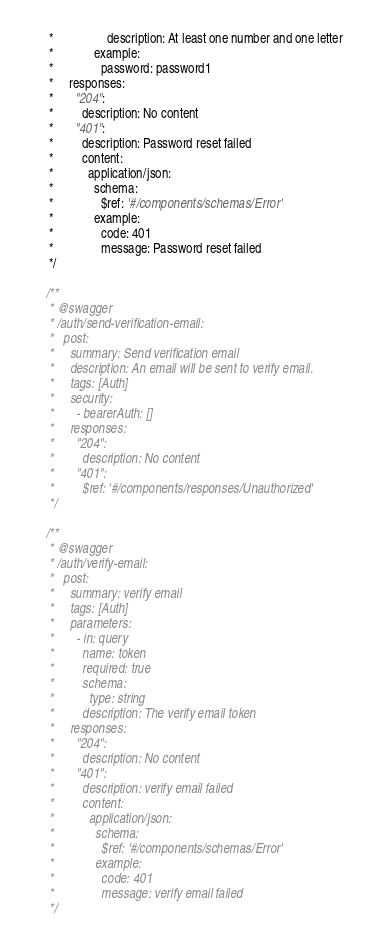Convert code to text. <code><loc_0><loc_0><loc_500><loc_500><_JavaScript_> *                 description: At least one number and one letter
 *             example:
 *               password: password1
 *     responses:
 *       "204":
 *         description: No content
 *       "401":
 *         description: Password reset failed
 *         content:
 *           application/json:
 *             schema:
 *               $ref: '#/components/schemas/Error'
 *             example:
 *               code: 401
 *               message: Password reset failed
 */

/**
 * @swagger
 * /auth/send-verification-email:
 *   post:
 *     summary: Send verification email
 *     description: An email will be sent to verify email.
 *     tags: [Auth]
 *     security:
 *       - bearerAuth: []
 *     responses:
 *       "204":
 *         description: No content
 *       "401":
 *         $ref: '#/components/responses/Unauthorized'
 */

/**
 * @swagger
 * /auth/verify-email:
 *   post:
 *     summary: verify email
 *     tags: [Auth]
 *     parameters:
 *       - in: query
 *         name: token
 *         required: true
 *         schema:
 *           type: string
 *         description: The verify email token
 *     responses:
 *       "204":
 *         description: No content
 *       "401":
 *         description: verify email failed
 *         content:
 *           application/json:
 *             schema:
 *               $ref: '#/components/schemas/Error'
 *             example:
 *               code: 401
 *               message: verify email failed
 */
</code> 